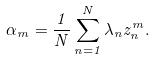Convert formula to latex. <formula><loc_0><loc_0><loc_500><loc_500>\alpha _ { m } = \frac { 1 } { N } \sum _ { n = 1 } ^ { N } \lambda _ { n } z _ { n } ^ { m } .</formula> 